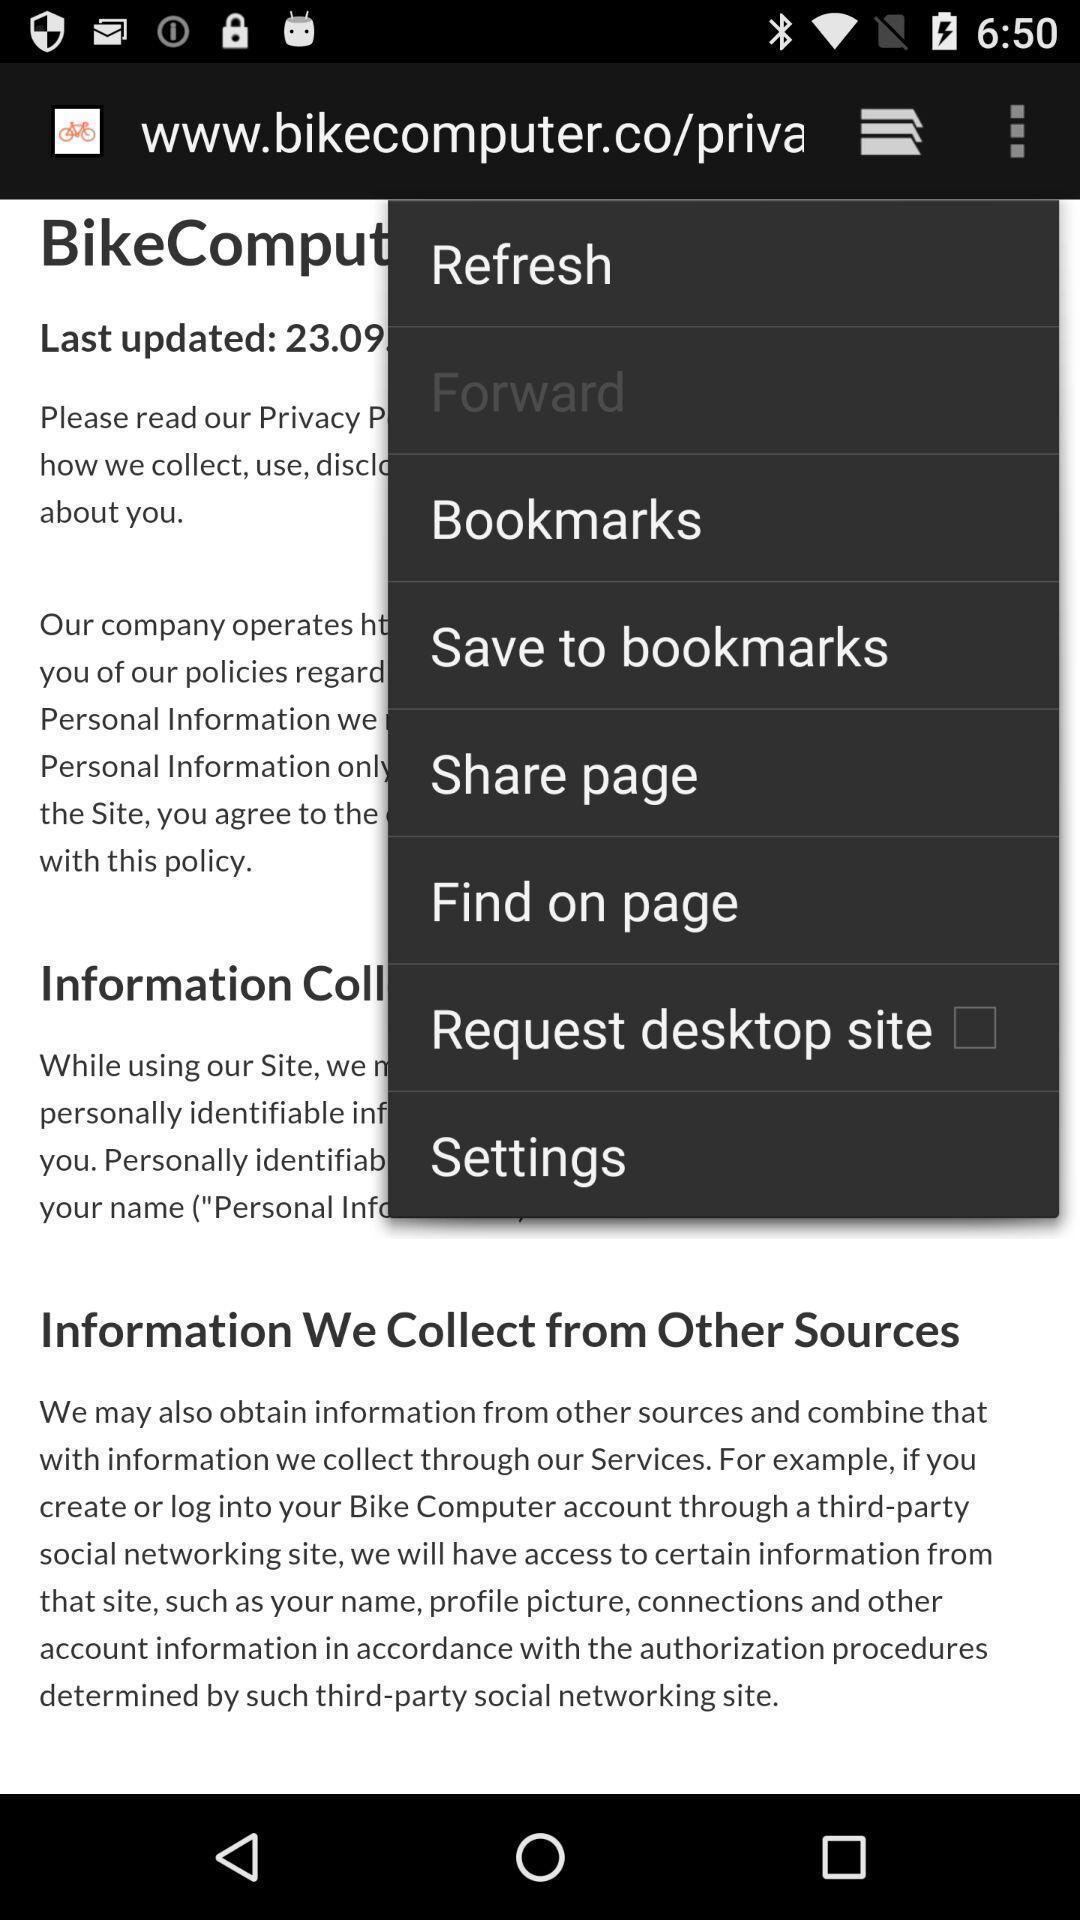Describe the key features of this screenshot. Pop-up showing menu of options for an application. 